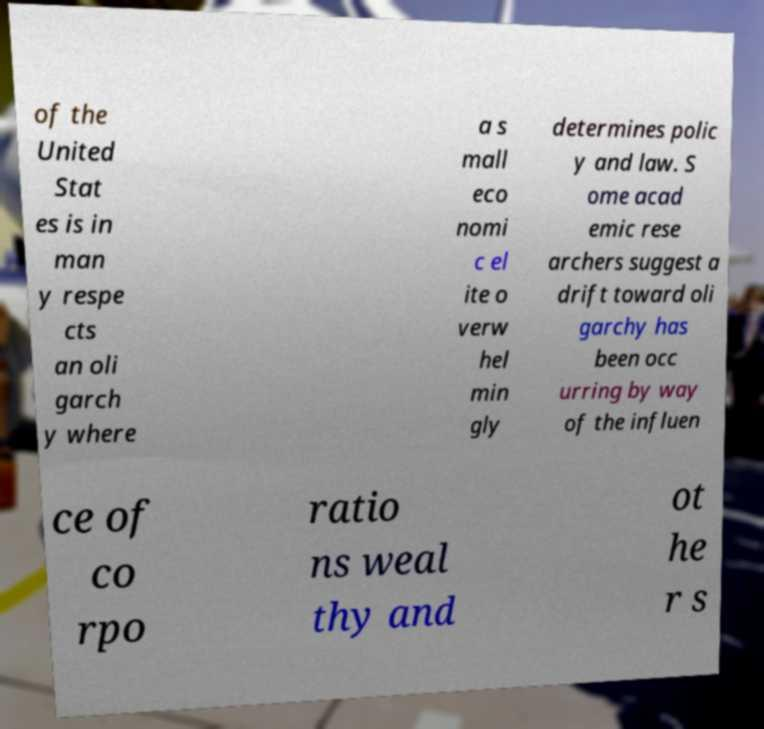Please identify and transcribe the text found in this image. of the United Stat es is in man y respe cts an oli garch y where a s mall eco nomi c el ite o verw hel min gly determines polic y and law. S ome acad emic rese archers suggest a drift toward oli garchy has been occ urring by way of the influen ce of co rpo ratio ns weal thy and ot he r s 